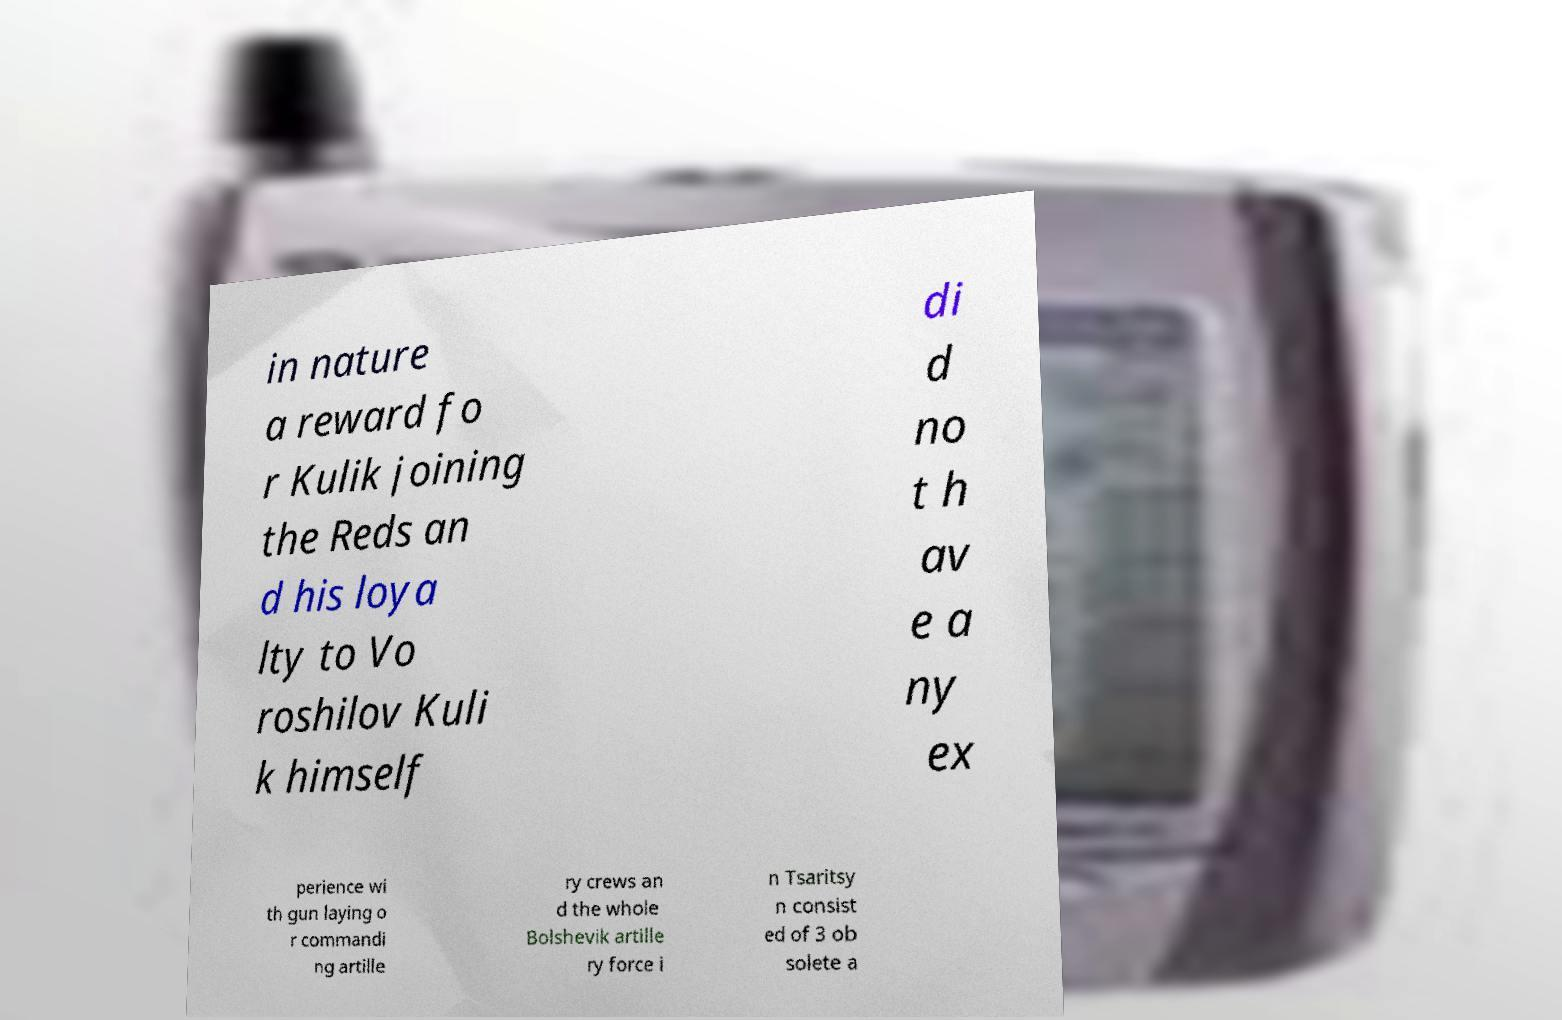Please identify and transcribe the text found in this image. in nature a reward fo r Kulik joining the Reds an d his loya lty to Vo roshilov Kuli k himself di d no t h av e a ny ex perience wi th gun laying o r commandi ng artille ry crews an d the whole Bolshevik artille ry force i n Tsaritsy n consist ed of 3 ob solete a 